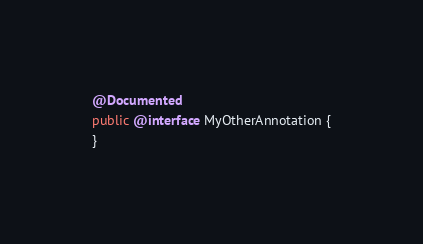<code> <loc_0><loc_0><loc_500><loc_500><_Java_>@Documented
public @interface MyOtherAnnotation {
}
</code> 